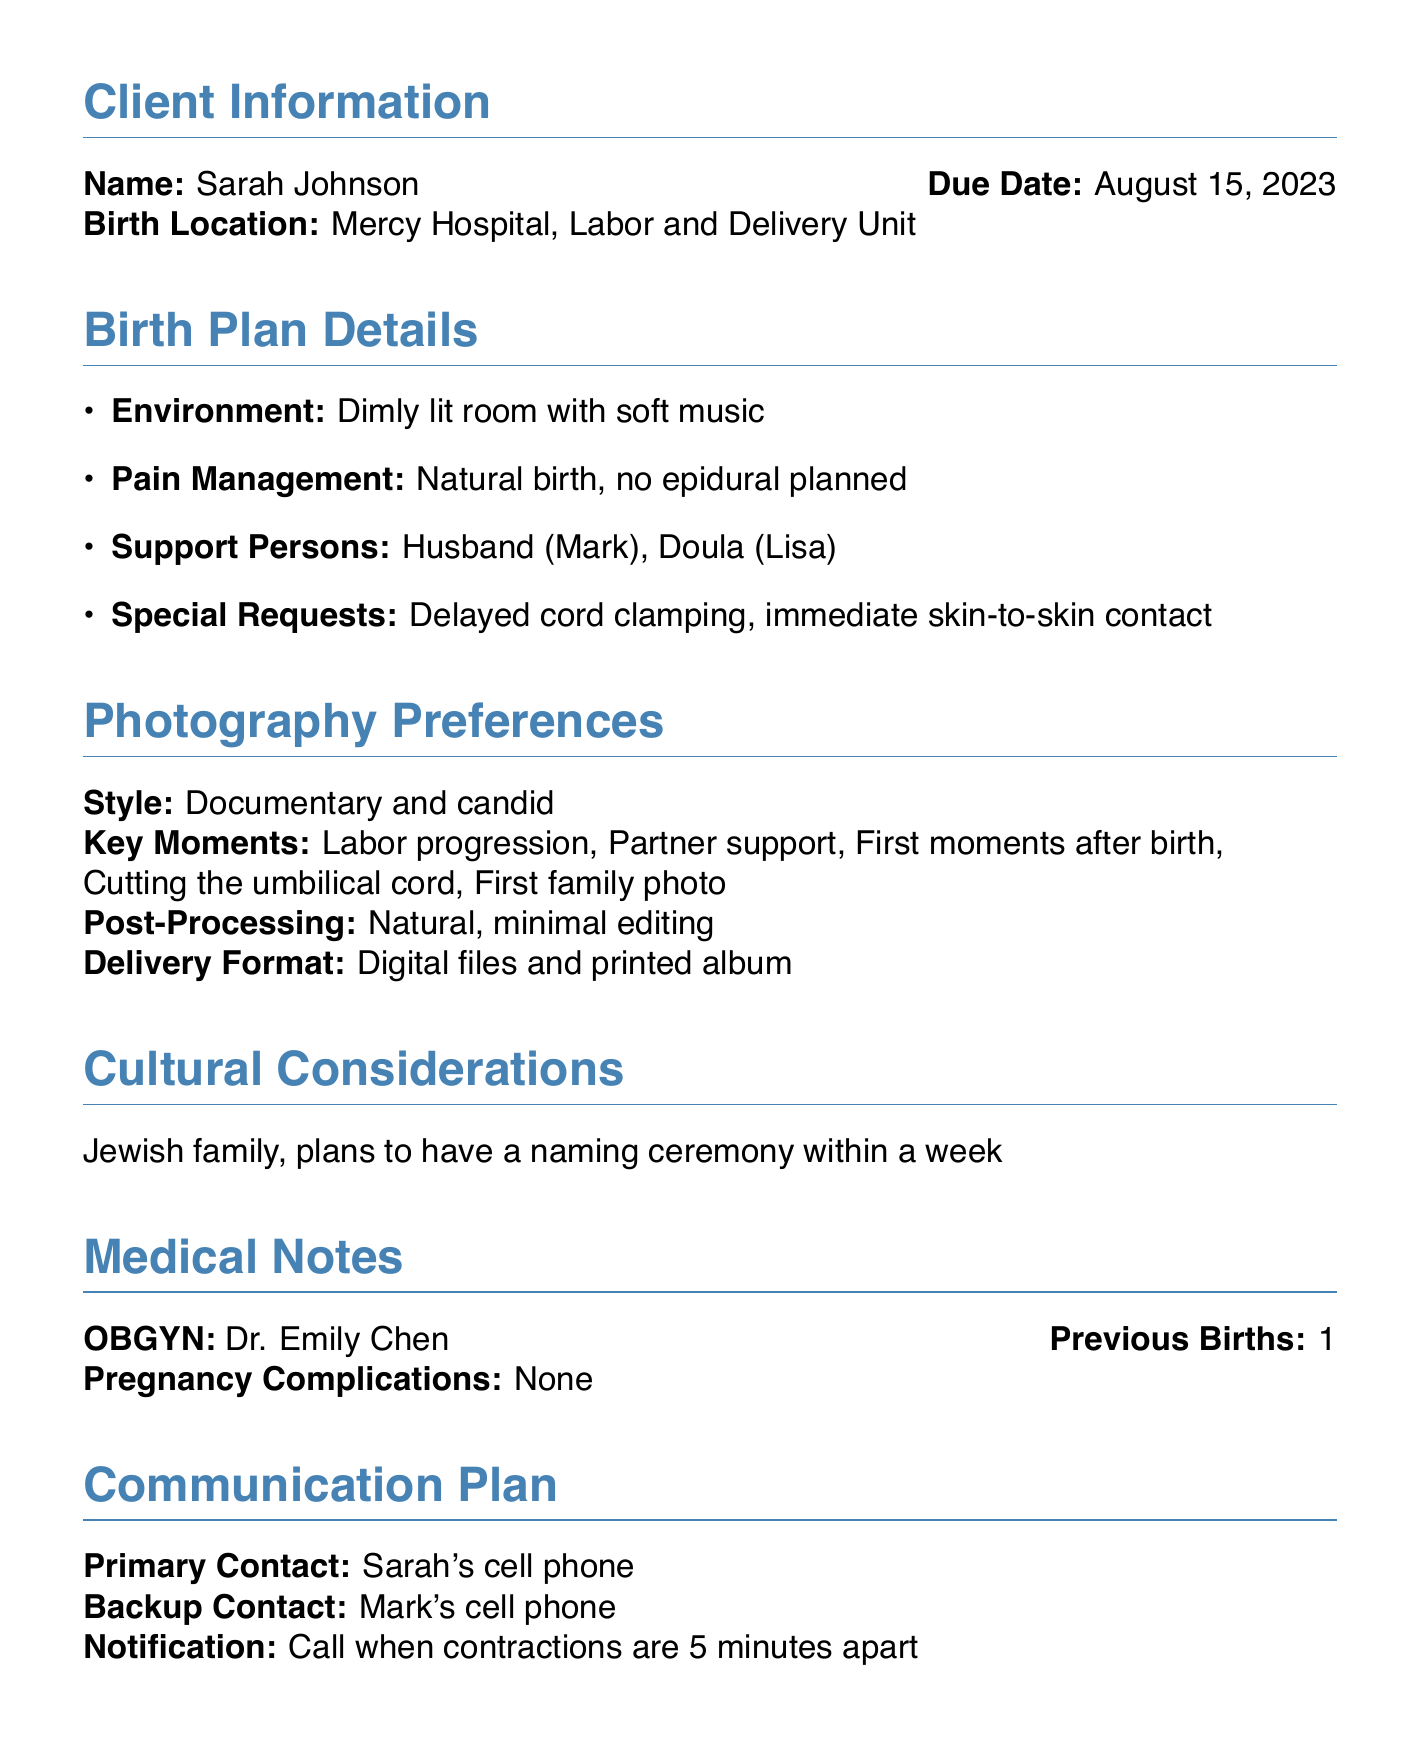What is the client's name? The client's name is found in the Client Information section.
Answer: Sarah Johnson What is the due date for the birth? The due date is listed in the Client Information section.
Answer: August 15, 2023 Where is the birth location? The birth location is mentioned in the Client Information section.
Answer: Mercy Hospital, Labor and Delivery Unit What type of birth is planned? The birth plan details state the type of pain management and approach to delivery.
Answer: Natural birth, no epidural planned Who are the support persons for the birth? The support persons are listed in the Birth Plan Details section.
Answer: Husband (Mark), Doula (Lisa) What is the requested post-processing style for photography? The photography preferences section specifies how photos will be edited.
Answer: Natural, minimal editing What are the key moments to be captured during the session? Key moments are specified in the Photography Preferences section.
Answer: Labor progression, Partner support, First moments after birth, Cutting the umbilical cord, First family photo What equipment is required for the session? Equipment notes detail the necessary gear for the photography session.
Answer: Silent shutter mode required What is the timeframe for the post-partum session? The post-partum session schedule is indicated within a specific time frame.
Answer: Within 2 weeks after birth What cultural considerations are noted? Cultural considerations are summarized in their section of the document.
Answer: Jewish family, plans to have a naming ceremony within a week 